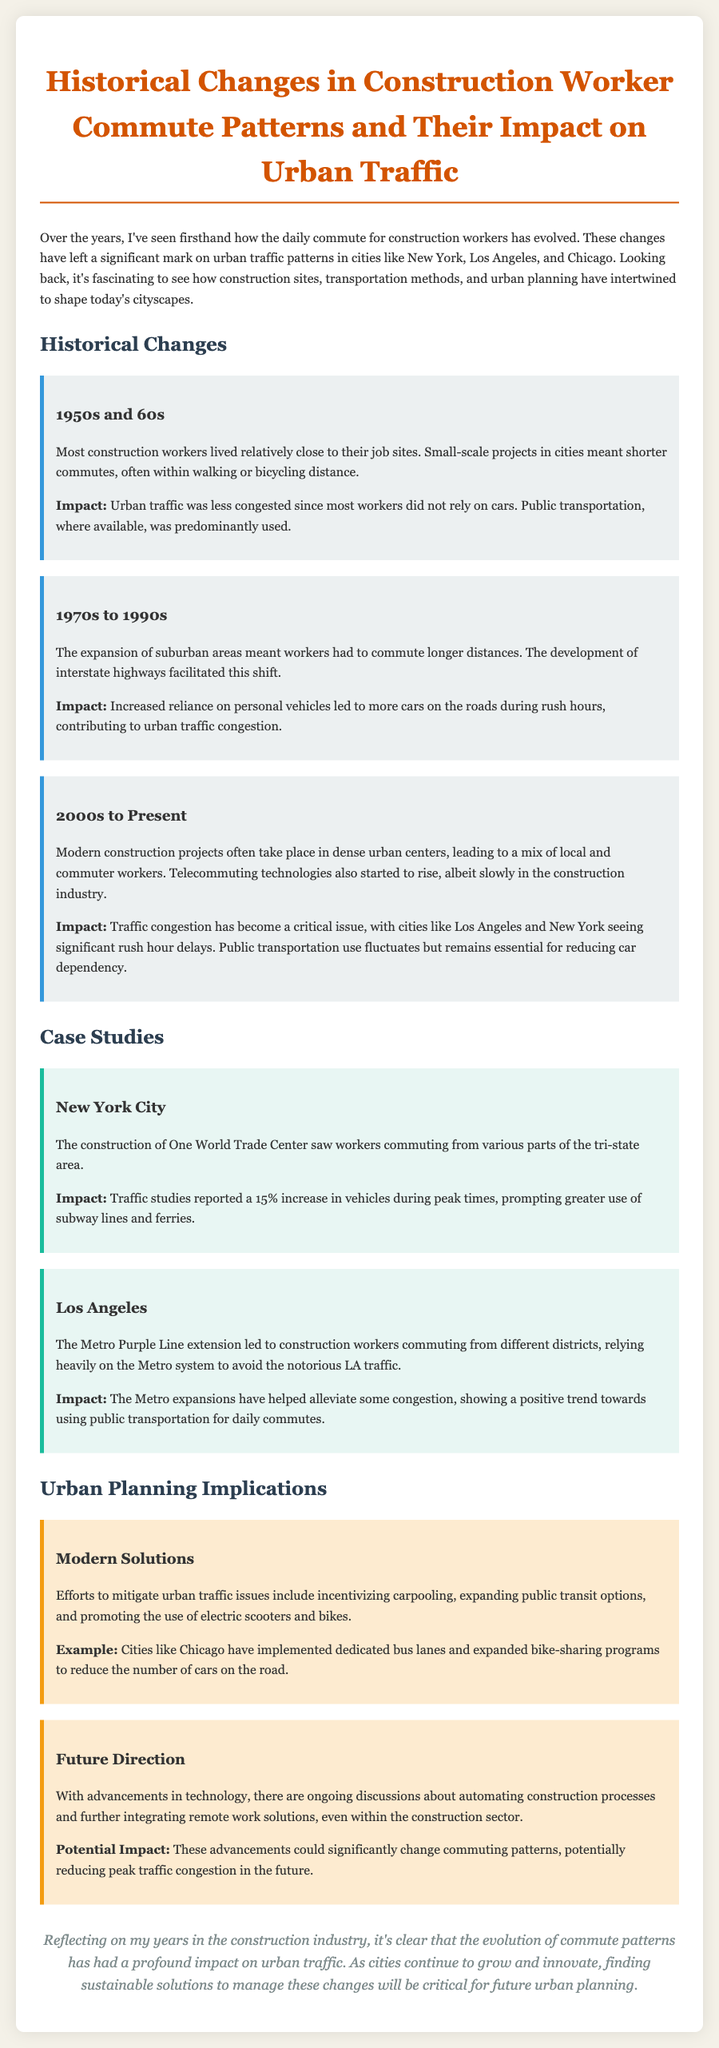What major cities are discussed in the document? The document mentions significant cities affected by changes in construction worker commute patterns, specifically New York, Los Angeles, and Chicago.
Answer: New York, Los Angeles, Chicago What was the impact of the 1950s and 60s commute patterns? The document states that during the 1950s and 60s, urban traffic was less congested as most workers did not rely on cars.
Answer: Less congested What increased during the 1970s to 1990s that affected urban traffic? The text mentions that an increased reliance on personal vehicles led to more cars on the roads during rush hours.
Answer: Reliance on personal vehicles What was the reported percentage increase in vehicles during peak times in New York City? The document notes that traffic studies reported a 15% increase in vehicles during peak times due to construction activities.
Answer: 15% What modern solutions are mentioned to mitigate urban traffic issues? The report discusses several solutions, including incentivizing carpooling, expanding public transit options, and promoting electric scooters and bikes.
Answer: Carpooling, public transit expansion, electric scooters, bikes What is one implication for urban planning discussed in the report? The text describes ongoing discussions about automating construction processes as a future direction for urban planning.
Answer: Automating construction processes What is a potential impact of advancements in technology on commuting patterns? The document suggests that advancements in technology could significantly change commuting patterns and reduce peak traffic congestion.
Answer: Reduce peak traffic congestion What construction project is referenced in Los Angeles? The report highlights the Metro Purple Line extension as a key project affecting commutes in Los Angeles.
Answer: Metro Purple Line extension 